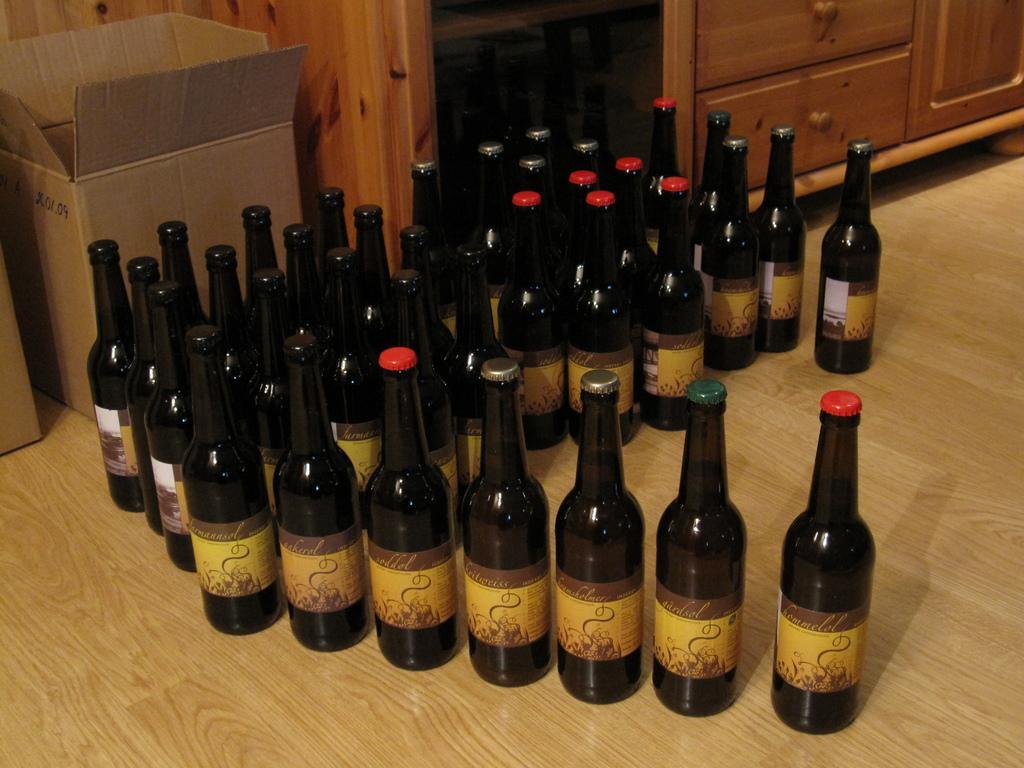In one or two sentences, can you explain what this image depicts? In this picture there are many bottles in which orange, grey, red , black caps are kept on the ground. A brown and a yellow label is seen on it. There are two boxes which are kept to the corner. A cupboard is visible on the right side. 